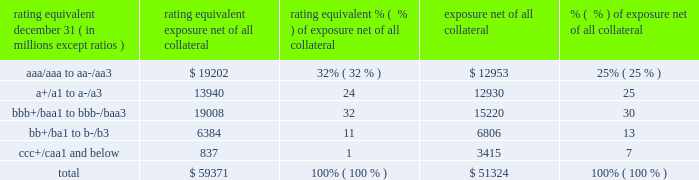Management 2019s discussion and analysis 126 jpmorgan chase & co./2014 annual report while useful as a current view of credit exposure , the net fair value of the derivative receivables does not capture the potential future variability of that credit exposure .
To capture the potential future variability of credit exposure , the firm calculates , on a client-by-client basis , three measures of potential derivatives-related credit loss : peak , derivative risk equivalent ( 201cdre 201d ) , and average exposure ( 201cavg 201d ) .
These measures all incorporate netting and collateral benefits , where applicable .
Peak exposure to a counterparty is an extreme measure of exposure calculated at a 97.5% ( 97.5 % ) confidence level .
Dre exposure is a measure that expresses the risk of derivative exposure on a basis intended to be equivalent to the risk of loan exposures .
The measurement is done by equating the unexpected loss in a derivative counterparty exposure ( which takes into consideration both the loss volatility and the credit rating of the counterparty ) with the unexpected loss in a loan exposure ( which takes into consideration only the credit rating of the counterparty ) .
Dre is a less extreme measure of potential credit loss than peak and is the primary measure used by the firm for credit approval of derivative transactions .
Finally , avg is a measure of the expected fair value of the firm 2019s derivative receivables at future time periods , including the benefit of collateral .
Avg exposure over the total life of the derivative contract is used as the primary metric for pricing purposes and is used to calculate credit capital and the cva , as further described below .
The three year avg exposure was $ 37.5 billion and $ 35.4 billion at december 31 , 2014 and 2013 , respectively , compared with derivative receivables , net of all collateral , of $ 59.4 billion and $ 51.3 billion at december 31 , 2014 and 2013 , respectively .
The fair value of the firm 2019s derivative receivables incorporates an adjustment , the cva , to reflect the credit quality of counterparties .
The cva is based on the firm 2019s avg to a counterparty and the counterparty 2019s credit spread in the credit derivatives market .
The primary components of changes in cva are credit spreads , new deal activity or unwinds , and changes in the underlying market environment .
The firm believes that active risk management is essential to controlling the dynamic credit risk in the derivatives portfolio .
In addition , the firm 2019s risk management process takes into consideration the potential impact of wrong-way risk , which is broadly defined as the potential for increased correlation between the firm 2019s exposure to a counterparty ( avg ) and the counterparty 2019s credit quality .
Many factors may influence the nature and magnitude of these correlations over time .
To the extent that these correlations are identified , the firm may adjust the cva associated with that counterparty 2019s avg .
The firm risk manages exposure to changes in cva by entering into credit derivative transactions , as well as interest rate , foreign exchange , equity and commodity derivative transactions .
The accompanying graph shows exposure profiles to the firm 2019s current derivatives portfolio over the next 10 years as calculated by the dre and avg metrics .
The two measures generally show that exposure will decline after the first year , if no new trades are added to the portfolio .
The table summarizes the ratings profile by derivative counterparty of the firm 2019s derivative receivables , including credit derivatives , net of other liquid securities collateral , for the dates indicated .
The ratings scale is based on the firm 2019s internal ratings , which generally correspond to the ratings as defined by s&p and moody 2019s .
Ratings profile of derivative receivables rating equivalent 2014 2013 ( a ) december 31 , ( in millions , except ratios ) exposure net of all collateral % (  % ) of exposure net of all collateral exposure net of all collateral % (  % ) of exposure net of all collateral .
( a ) the prior period amounts have been revised to conform with the current period presentation. .
What was the ratio of the ratings profile of derivative receivables rating equivalent of the aaa/aaa to aa-/aa3 to the a+/a1 to a-/a3? 
Computations: (19202 / 13940)
Answer: 1.37747. 